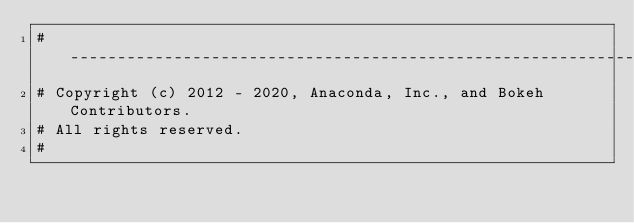<code> <loc_0><loc_0><loc_500><loc_500><_Python_>#-----------------------------------------------------------------------------
# Copyright (c) 2012 - 2020, Anaconda, Inc., and Bokeh Contributors.
# All rights reserved.
#</code> 